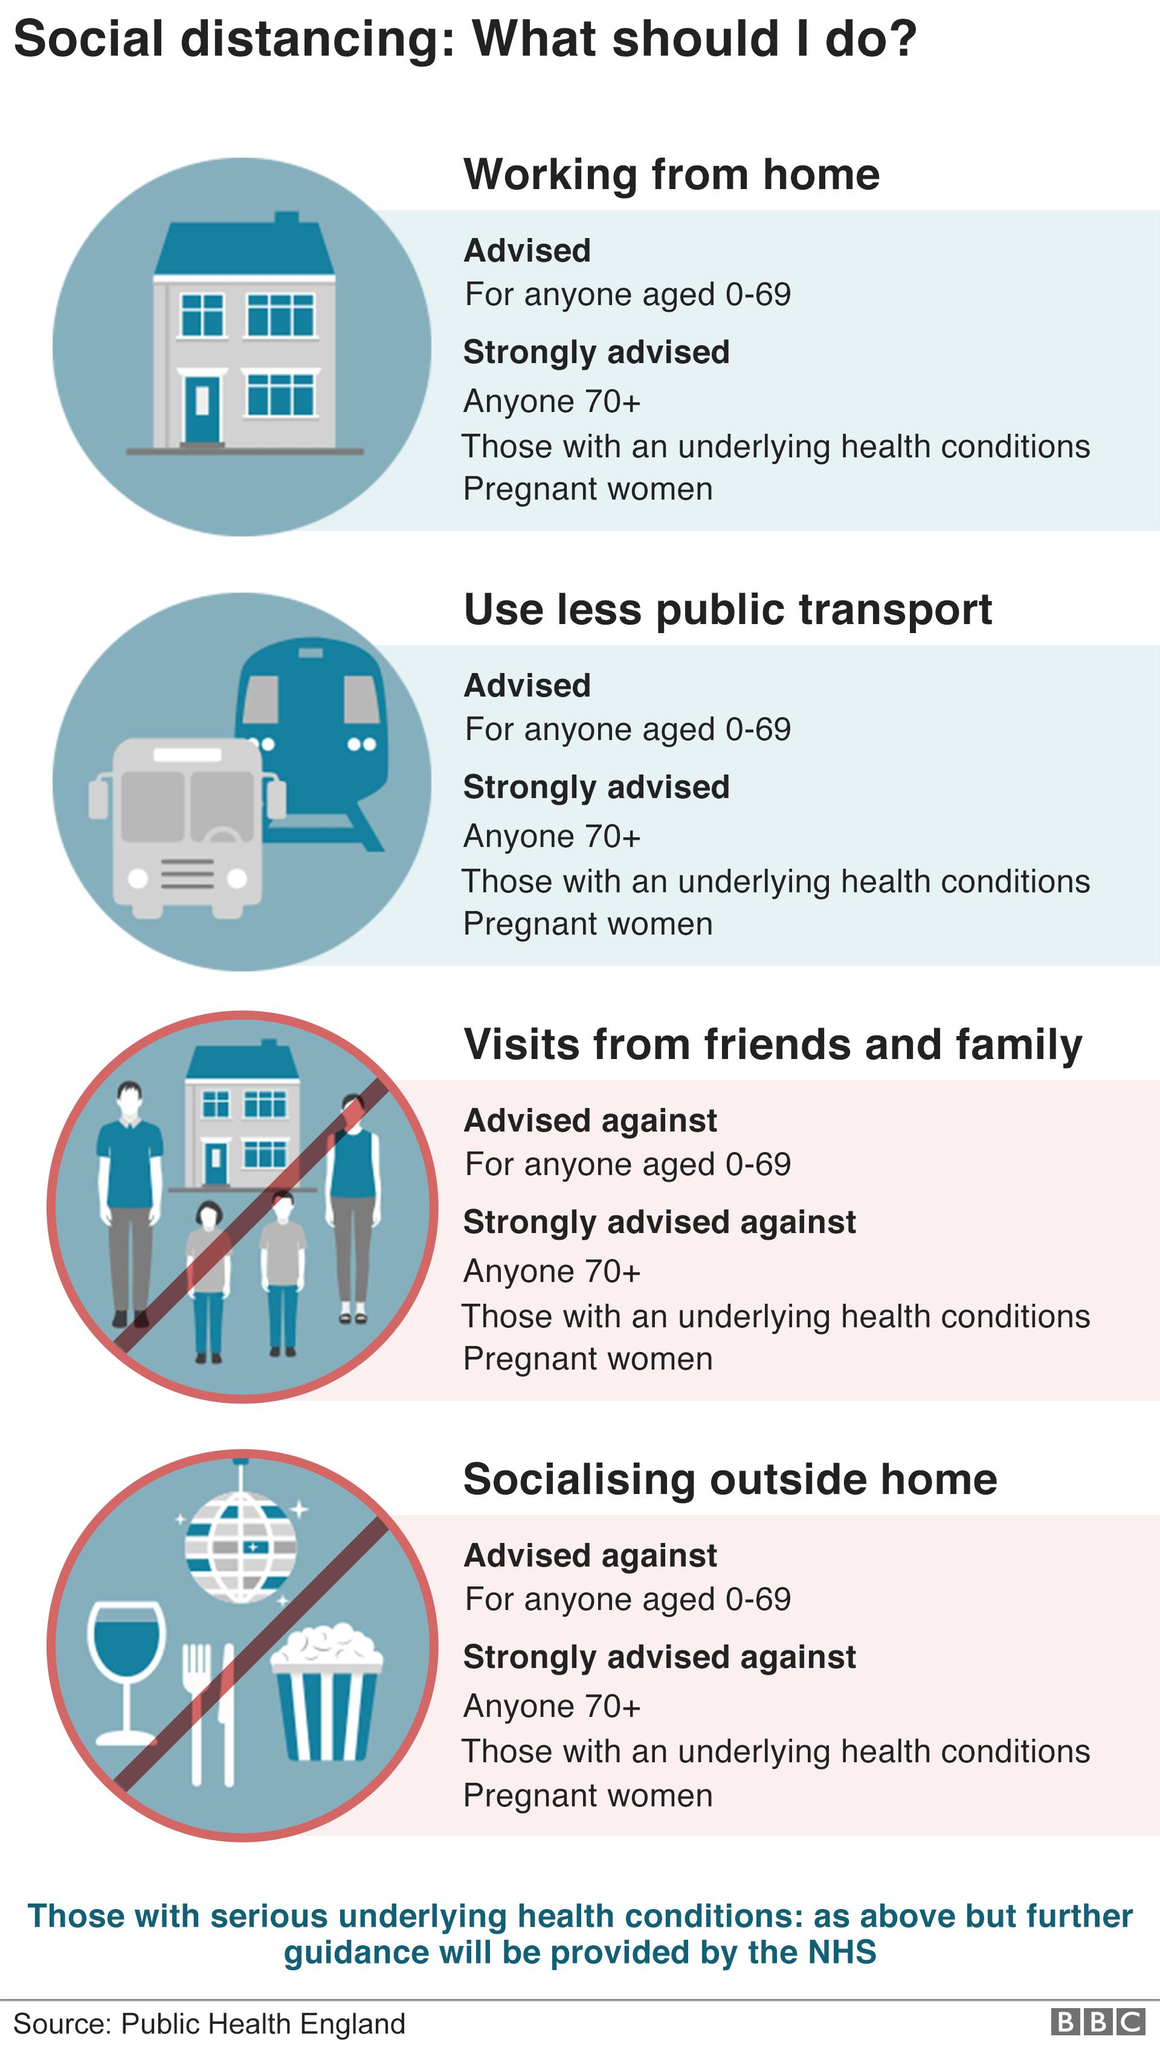Indicate a few pertinent items in this graphic. It is advisable to refrain from both visiting friends and family and socializing outside the home. Four pieces of advice are provided in this context. Not doing the advices given is two of them. The first image depicts a family, a mode of transport, and a home, with the focus being on the home. It is advised to pregnant women to use less public transportation in order to ensure their safety and well-being. 